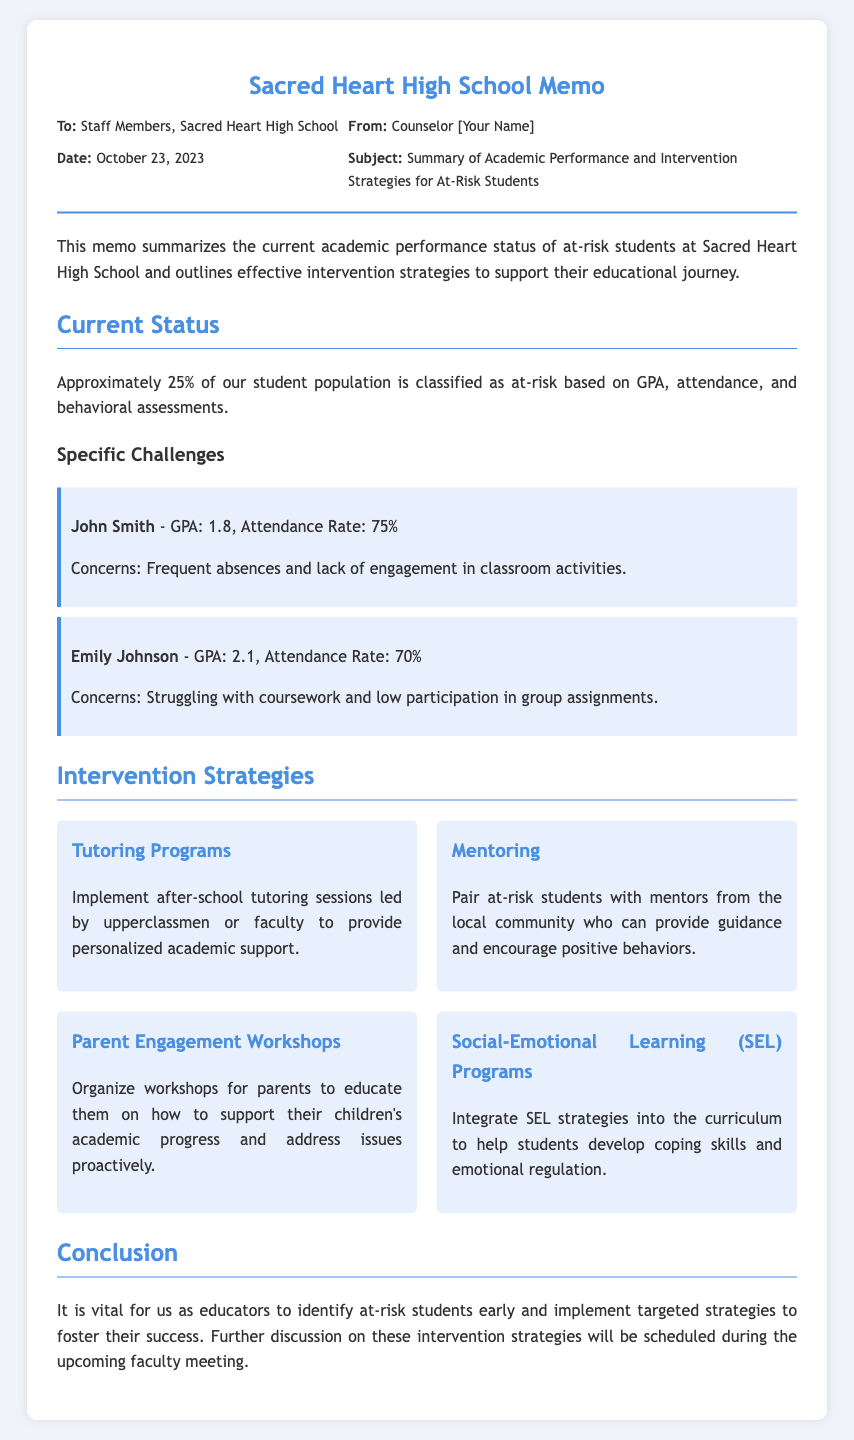what is the date of the memo? The date of the memo is mentioned in the metadata section of the document.
Answer: October 23, 2023 how many students are classified as at-risk? The memo states a percentage of the student population classified as at-risk, based on several assessments.
Answer: 25% who is the student with the lowest GPA mentioned? The memo provides specific GPA details for students and identifies the one with the lowest GPA.
Answer: John Smith what type of program is suggested for academic support? The memo lists specific strategies to intervene with at-risk students, one of which provides academic assistance.
Answer: Tutoring Programs what is one concern for Emily Johnson? The memo highlights specific issues faced by Emily Johnson, detailing her struggles in academics.
Answer: Struggling with coursework name one community role suggested in the intervention strategies. The memo discusses the involvement of certain individuals in supporting at-risk students.
Answer: Mentors what is one strategy aimed at improving parent involvement? The memo outlines intervention strategies, including those directed at engaging parents in their children's education.
Answer: Parent Engagement Workshops how does the memo categorize the learners mentioned? The memo classifies students based on academic performance and engagement levels.
Answer: At-risk students what is a focus of the Social-Emotional Learning Programs mentioned? The memo describes the purpose of integrating specific programs into the educational curriculum.
Answer: Emotional regulation 